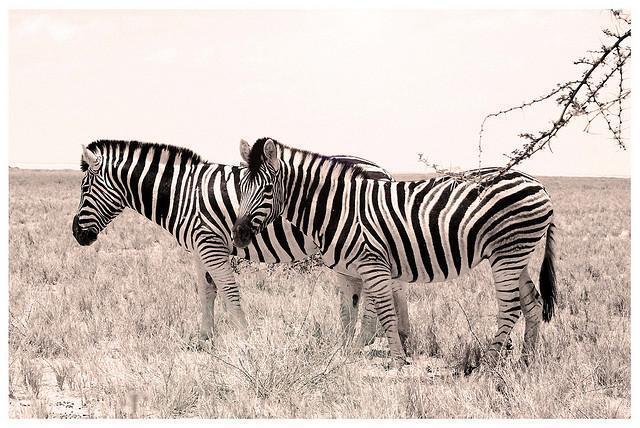How many zebras are in the photo?
Give a very brief answer. 2. How many zebras are in the picture?
Give a very brief answer. 2. How many people are wearing pink shirts?
Give a very brief answer. 0. 